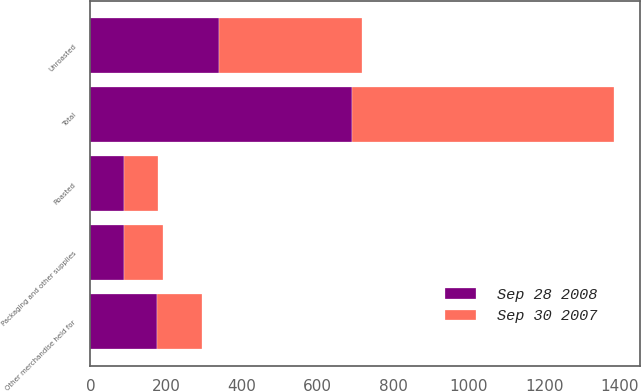Convert chart to OTSL. <chart><loc_0><loc_0><loc_500><loc_500><stacked_bar_chart><ecel><fcel>Unroasted<fcel>Roasted<fcel>Other merchandise held for<fcel>Packaging and other supplies<fcel>Total<nl><fcel>Sep 30 2007<fcel>377.7<fcel>89.6<fcel>120.6<fcel>104.9<fcel>692.8<nl><fcel>Sep 28 2008<fcel>339.5<fcel>88.6<fcel>175.5<fcel>88.1<fcel>691.7<nl></chart> 